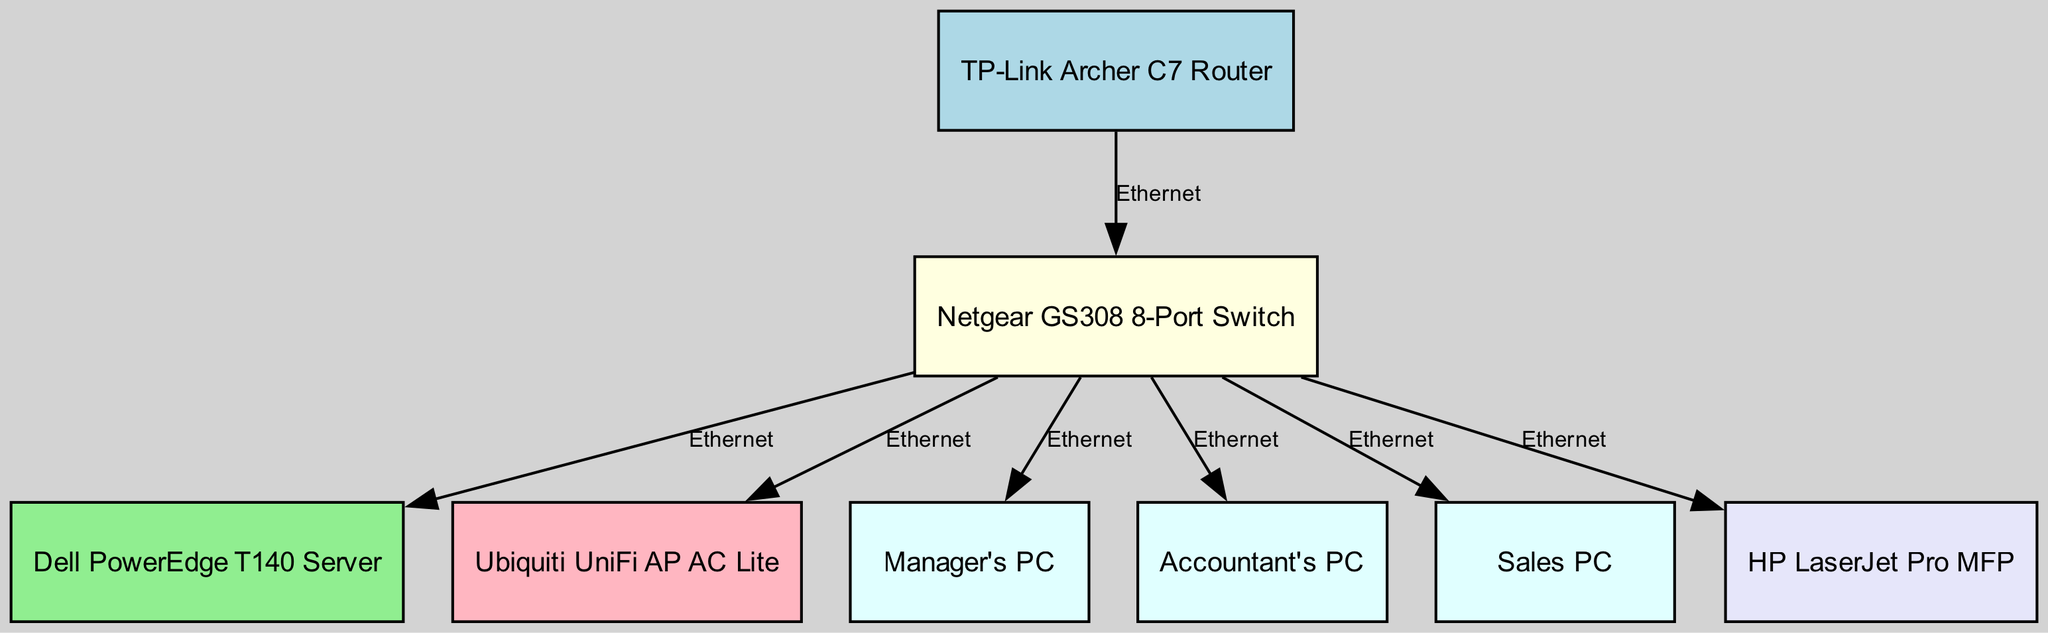What is the total number of nodes in the diagram? The diagram contains nodes representing network devices, including the router, switch, server, wireless access point, three PCs, and a printer. Counting these nodes gives a total of 8.
Answer: 8 What type of device is connected directly to the switch and has the label "Dell PowerEdge T140 Server"? The server is the device connected directly to the switch, and it is identified by its specific label in the diagram.
Answer: Server How many PCs are shown in the diagram? The diagram lists three PCs identified by their labels connected to the switch. Thus, the total is three.
Answer: 3 What is the connection type between the router and the switch? The connection type indicated between these two devices is specified as "Ethernet," establishing how they communicate within the network.
Answer: Ethernet Which device is connected to the switch and labeled as "Ubiquiti UniFi AP AC Lite"? The device with this label is the wireless access point (WAP), which shows the purpose of enhancing wireless connectivity within the network layout.
Answer: Ubiquiti UniFi AP AC Lite What is the edge label connecting the switch to the printer? The edge connecting these two devices is labeled "Ethernet," denoting the standard connection method used for network communication.
Answer: Ethernet Which node serves as the central hub for most connections in the diagram? The switch acts as the central hub, connecting multiple devices directly to it as shown, allowing efficient network communication.
Answer: Switch Which device is connected to the switch but not displaying a PC label? The device labeled "Dell PowerEdge T140 Server" is the one connected to the switch that does not have a PC label, confirming it's a server in the network.
Answer: Dell PowerEdge T140 Server 